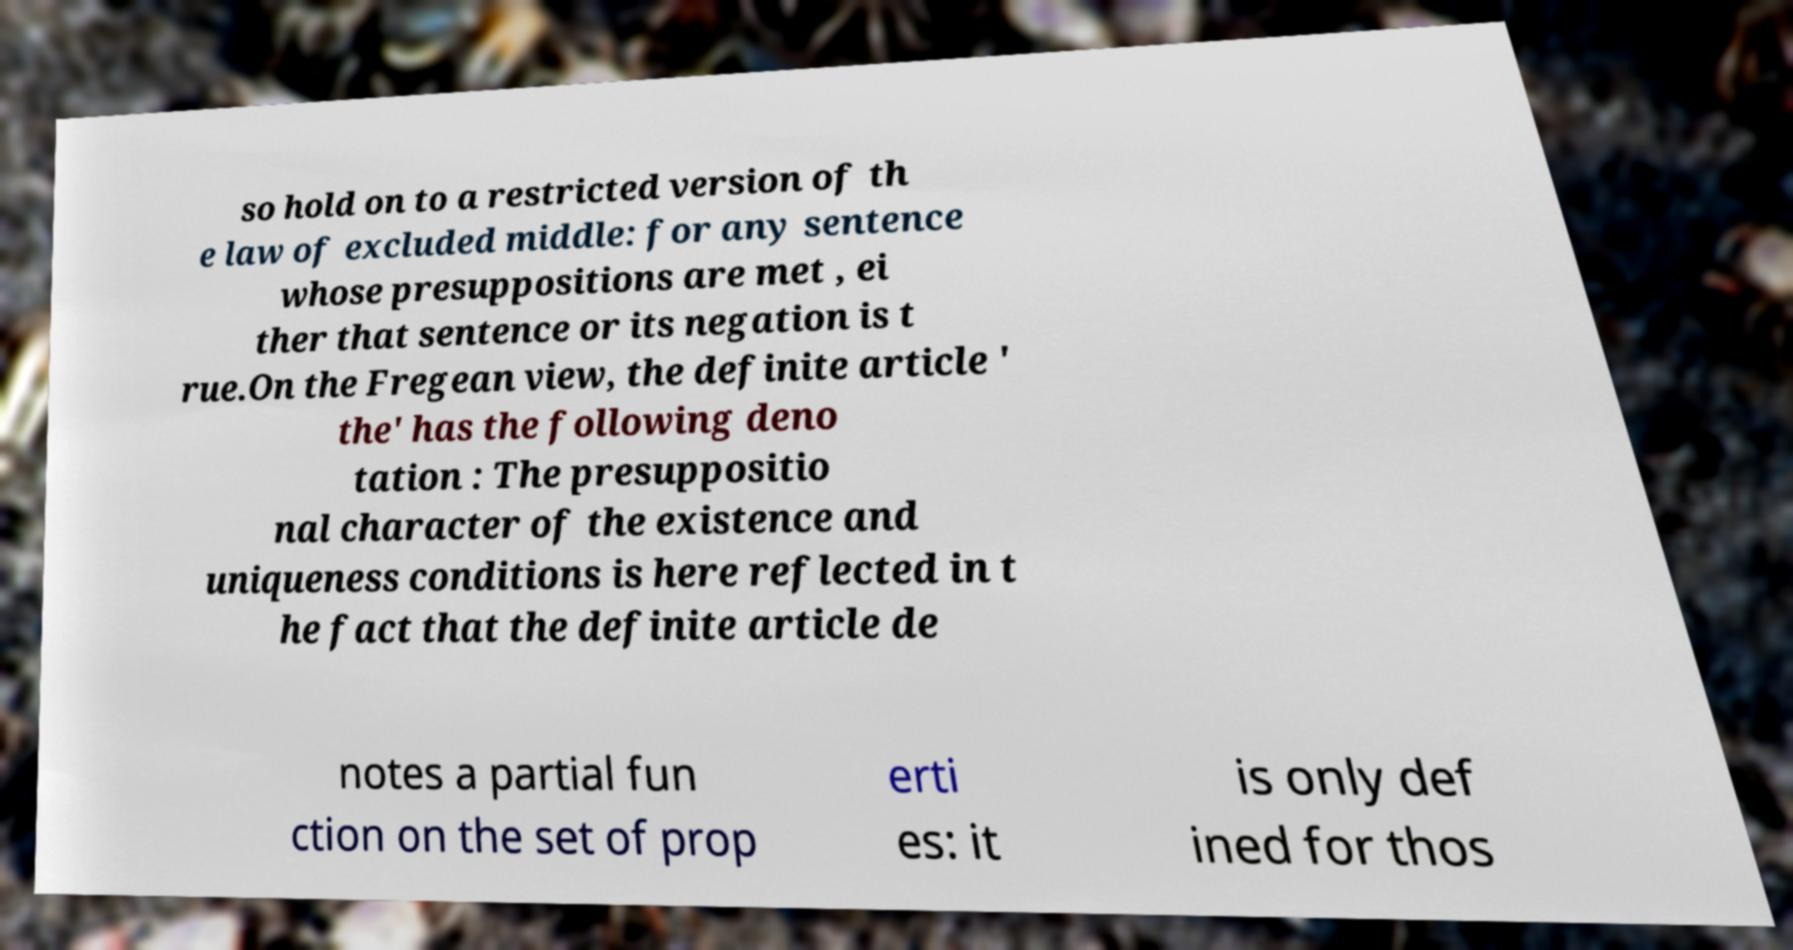There's text embedded in this image that I need extracted. Can you transcribe it verbatim? so hold on to a restricted version of th e law of excluded middle: for any sentence whose presuppositions are met , ei ther that sentence or its negation is t rue.On the Fregean view, the definite article ' the' has the following deno tation : The presuppositio nal character of the existence and uniqueness conditions is here reflected in t he fact that the definite article de notes a partial fun ction on the set of prop erti es: it is only def ined for thos 